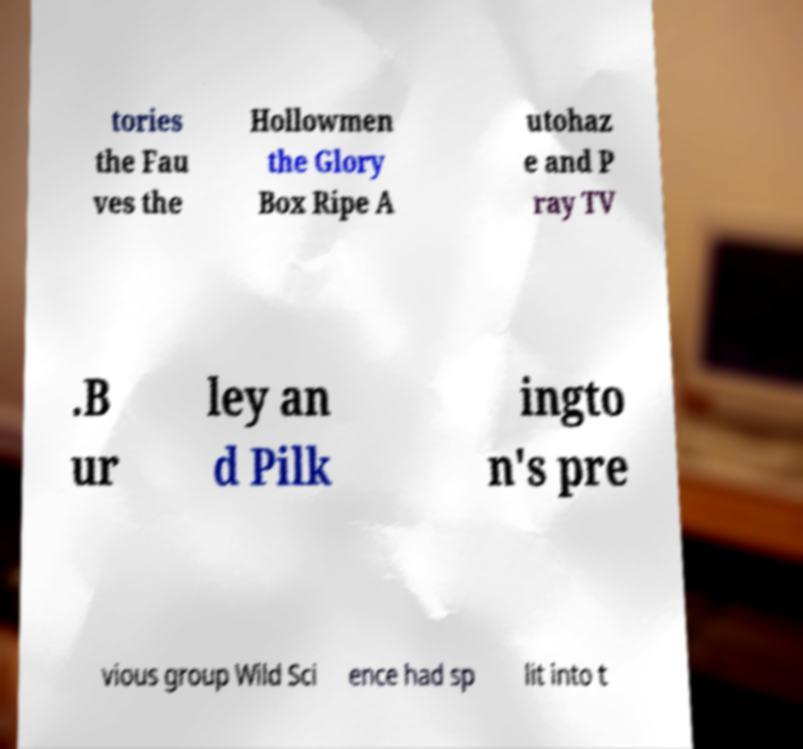Could you extract and type out the text from this image? tories the Fau ves the Hollowmen the Glory Box Ripe A utohaz e and P ray TV .B ur ley an d Pilk ingto n's pre vious group Wild Sci ence had sp lit into t 